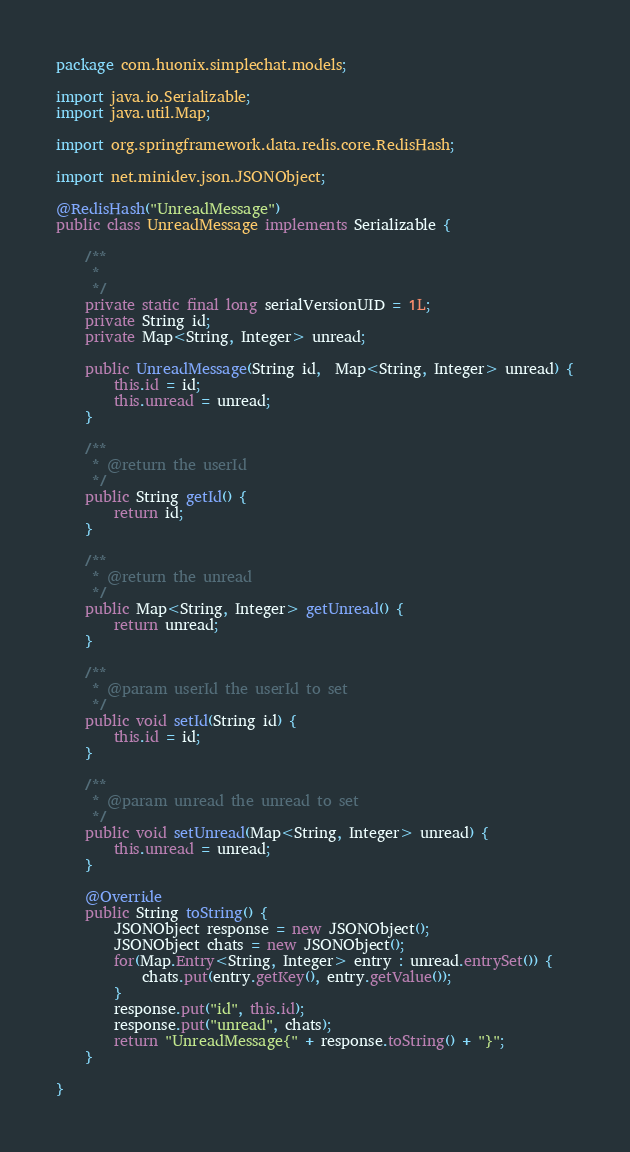<code> <loc_0><loc_0><loc_500><loc_500><_Java_>package com.huonix.simplechat.models;

import java.io.Serializable;
import java.util.Map;

import org.springframework.data.redis.core.RedisHash;

import net.minidev.json.JSONObject;

@RedisHash("UnreadMessage")
public class UnreadMessage implements Serializable {

	/**
	 * 
	 */
	private static final long serialVersionUID = 1L;
	private String id;
	private Map<String, Integer> unread;
	
	public UnreadMessage(String id,  Map<String, Integer> unread) {
		this.id = id;
		this.unread = unread;
	}

	/**
	 * @return the userId
	 */
	public String getId() {
		return id;
	}

	/**
	 * @return the unread
	 */
	public Map<String, Integer> getUnread() {
		return unread;
	}

	/**
	 * @param userId the userId to set
	 */
	public void setId(String id) {
		this.id = id;
	}

	/**
	 * @param unread the unread to set
	 */
	public void setUnread(Map<String, Integer> unread) {
		this.unread = unread;
	}
	
	@Override
	public String toString() {
		JSONObject response = new JSONObject();
		JSONObject chats = new JSONObject();
		for(Map.Entry<String, Integer> entry : unread.entrySet()) {
			chats.put(entry.getKey(), entry.getValue());
		}
		response.put("id", this.id);
		response.put("unread", chats);
		return "UnreadMessage{" + response.toString() + "}";
	}	
	
}
</code> 